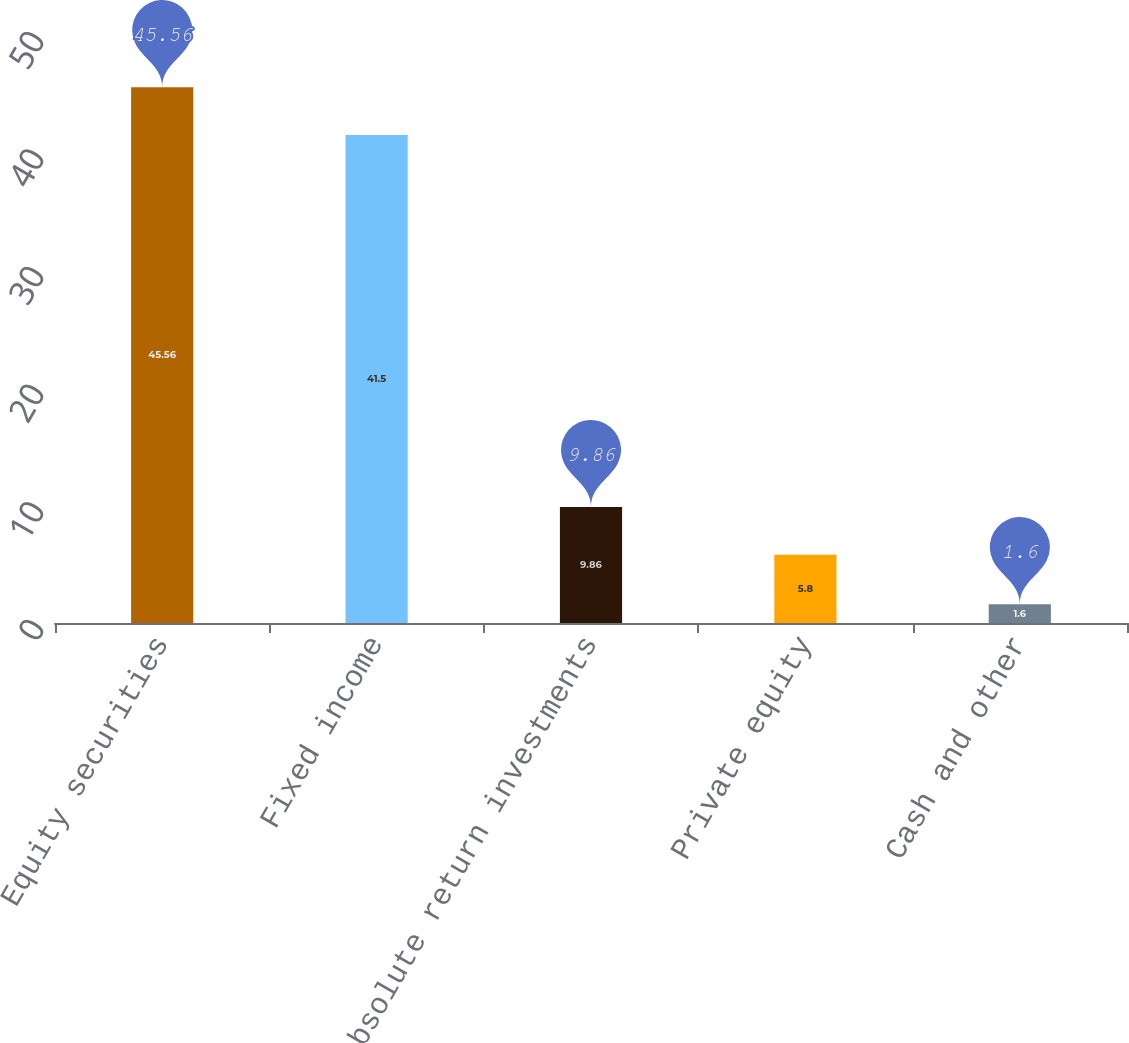<chart> <loc_0><loc_0><loc_500><loc_500><bar_chart><fcel>Equity securities<fcel>Fixed income<fcel>Absolute return investments<fcel>Private equity<fcel>Cash and other<nl><fcel>45.56<fcel>41.5<fcel>9.86<fcel>5.8<fcel>1.6<nl></chart> 